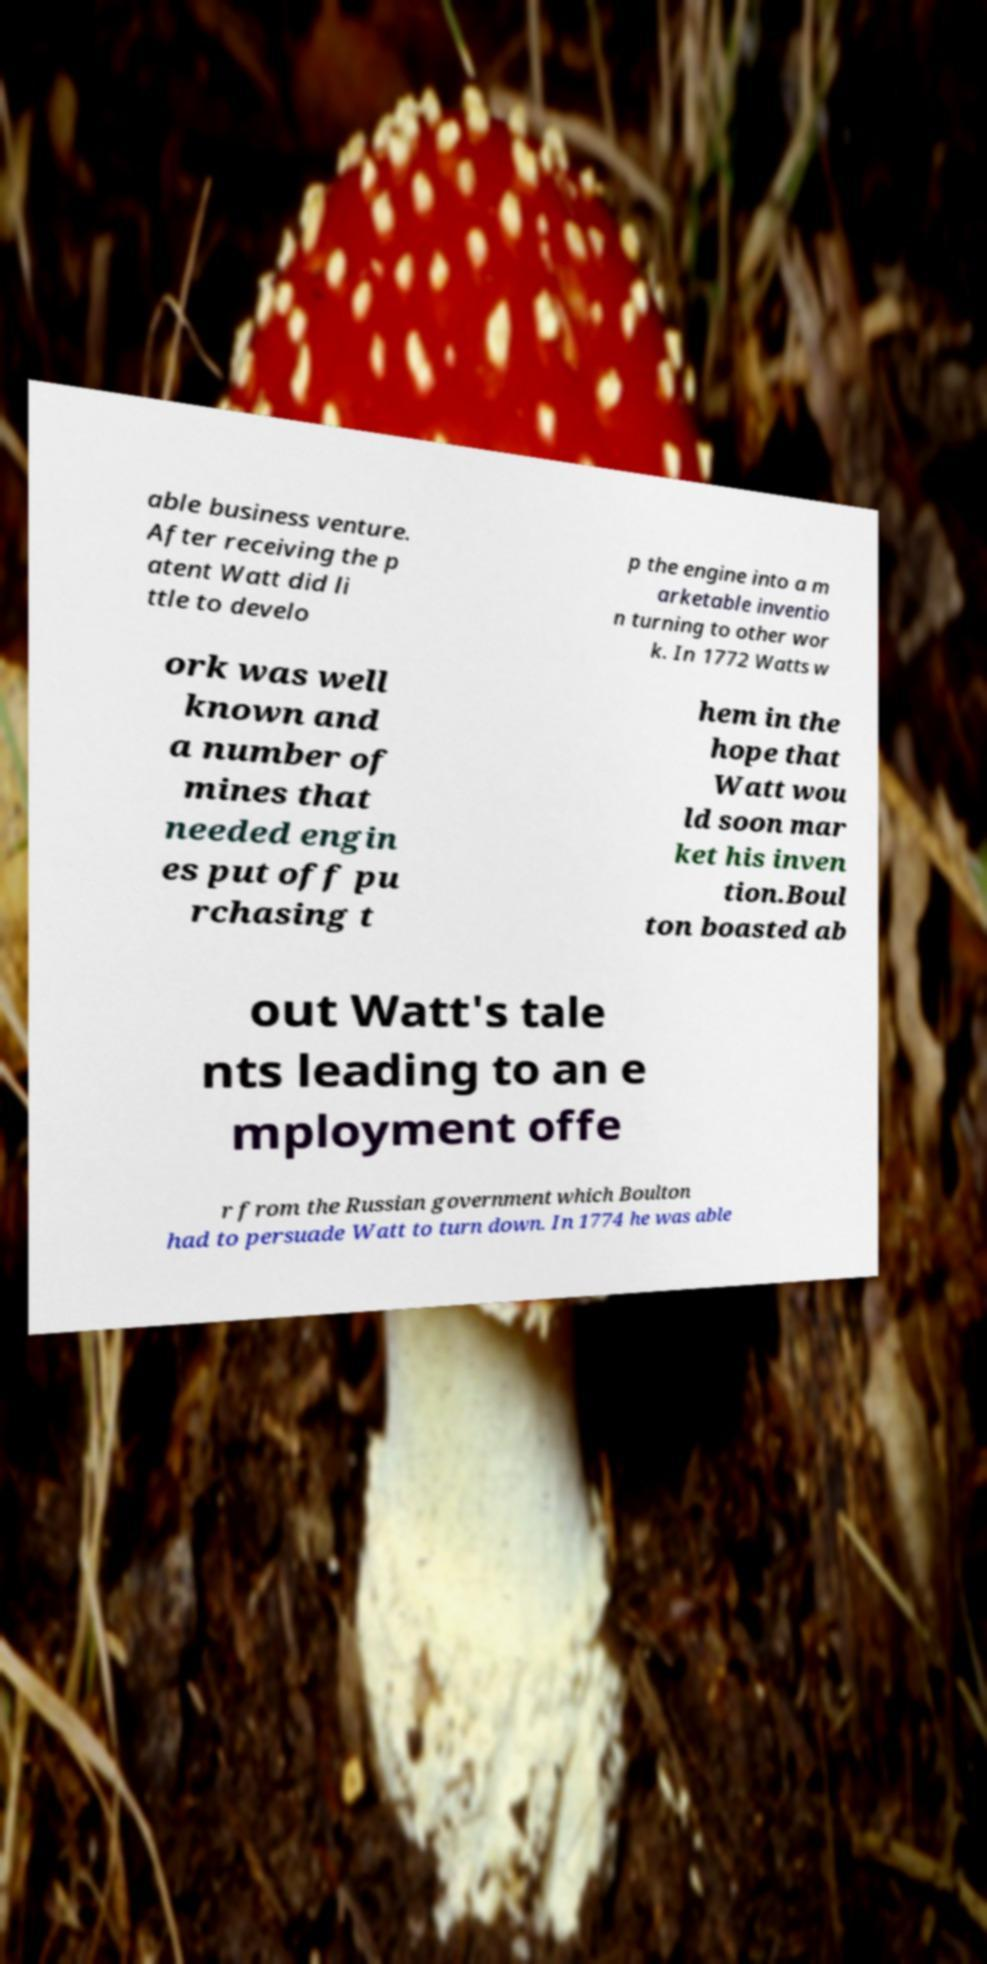Could you assist in decoding the text presented in this image and type it out clearly? able business venture. After receiving the p atent Watt did li ttle to develo p the engine into a m arketable inventio n turning to other wor k. In 1772 Watts w ork was well known and a number of mines that needed engin es put off pu rchasing t hem in the hope that Watt wou ld soon mar ket his inven tion.Boul ton boasted ab out Watt's tale nts leading to an e mployment offe r from the Russian government which Boulton had to persuade Watt to turn down. In 1774 he was able 